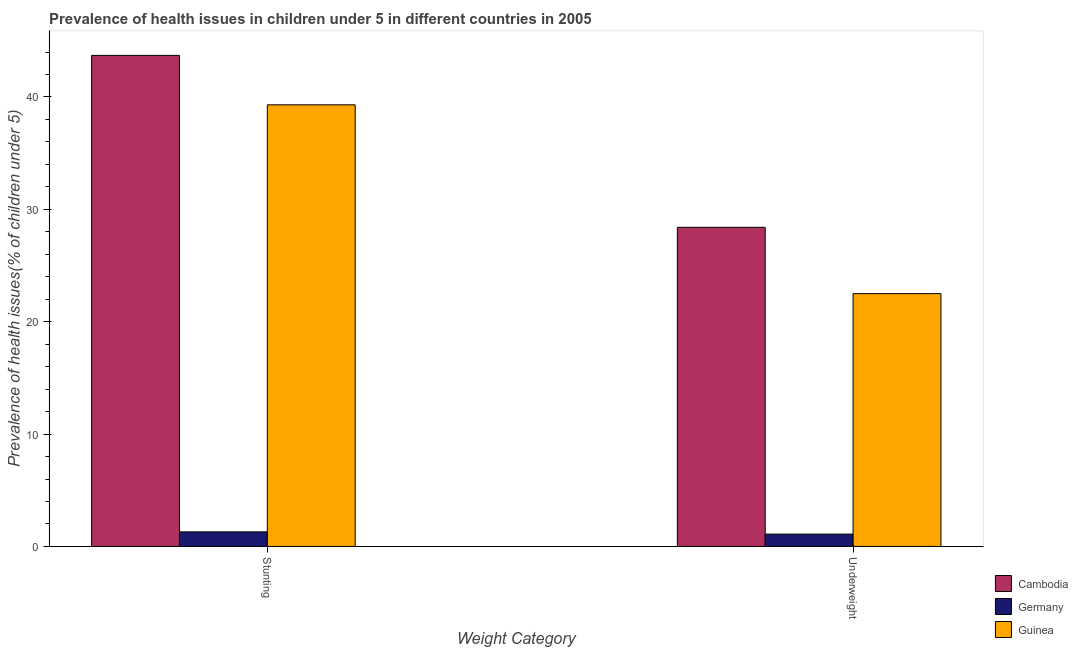Are the number of bars on each tick of the X-axis equal?
Make the answer very short. Yes. What is the label of the 1st group of bars from the left?
Your response must be concise. Stunting. What is the percentage of stunted children in Guinea?
Provide a succinct answer. 39.3. Across all countries, what is the maximum percentage of stunted children?
Give a very brief answer. 43.7. Across all countries, what is the minimum percentage of underweight children?
Your answer should be very brief. 1.1. In which country was the percentage of underweight children maximum?
Your response must be concise. Cambodia. What is the total percentage of stunted children in the graph?
Keep it short and to the point. 84.3. What is the difference between the percentage of stunted children in Guinea and that in Germany?
Keep it short and to the point. 38. What is the difference between the percentage of underweight children in Cambodia and the percentage of stunted children in Germany?
Give a very brief answer. 27.1. What is the average percentage of underweight children per country?
Your answer should be compact. 17.33. What is the difference between the percentage of underweight children and percentage of stunted children in Guinea?
Your answer should be compact. -16.8. In how many countries, is the percentage of stunted children greater than 40 %?
Your answer should be very brief. 1. What is the ratio of the percentage of underweight children in Cambodia to that in Guinea?
Offer a terse response. 1.26. In how many countries, is the percentage of stunted children greater than the average percentage of stunted children taken over all countries?
Give a very brief answer. 2. What does the 1st bar from the right in Underweight represents?
Your answer should be compact. Guinea. How many bars are there?
Offer a terse response. 6. Are all the bars in the graph horizontal?
Provide a short and direct response. No. What is the difference between two consecutive major ticks on the Y-axis?
Your answer should be very brief. 10. Are the values on the major ticks of Y-axis written in scientific E-notation?
Offer a very short reply. No. How are the legend labels stacked?
Ensure brevity in your answer.  Vertical. What is the title of the graph?
Ensure brevity in your answer.  Prevalence of health issues in children under 5 in different countries in 2005. What is the label or title of the X-axis?
Provide a succinct answer. Weight Category. What is the label or title of the Y-axis?
Make the answer very short. Prevalence of health issues(% of children under 5). What is the Prevalence of health issues(% of children under 5) of Cambodia in Stunting?
Your answer should be very brief. 43.7. What is the Prevalence of health issues(% of children under 5) of Germany in Stunting?
Your response must be concise. 1.3. What is the Prevalence of health issues(% of children under 5) of Guinea in Stunting?
Keep it short and to the point. 39.3. What is the Prevalence of health issues(% of children under 5) in Cambodia in Underweight?
Offer a terse response. 28.4. What is the Prevalence of health issues(% of children under 5) of Germany in Underweight?
Provide a succinct answer. 1.1. Across all Weight Category, what is the maximum Prevalence of health issues(% of children under 5) of Cambodia?
Provide a succinct answer. 43.7. Across all Weight Category, what is the maximum Prevalence of health issues(% of children under 5) of Germany?
Give a very brief answer. 1.3. Across all Weight Category, what is the maximum Prevalence of health issues(% of children under 5) of Guinea?
Your response must be concise. 39.3. Across all Weight Category, what is the minimum Prevalence of health issues(% of children under 5) in Cambodia?
Provide a succinct answer. 28.4. Across all Weight Category, what is the minimum Prevalence of health issues(% of children under 5) in Germany?
Provide a succinct answer. 1.1. What is the total Prevalence of health issues(% of children under 5) of Cambodia in the graph?
Make the answer very short. 72.1. What is the total Prevalence of health issues(% of children under 5) in Guinea in the graph?
Your answer should be very brief. 61.8. What is the difference between the Prevalence of health issues(% of children under 5) of Cambodia in Stunting and the Prevalence of health issues(% of children under 5) of Germany in Underweight?
Make the answer very short. 42.6. What is the difference between the Prevalence of health issues(% of children under 5) in Cambodia in Stunting and the Prevalence of health issues(% of children under 5) in Guinea in Underweight?
Give a very brief answer. 21.2. What is the difference between the Prevalence of health issues(% of children under 5) of Germany in Stunting and the Prevalence of health issues(% of children under 5) of Guinea in Underweight?
Provide a succinct answer. -21.2. What is the average Prevalence of health issues(% of children under 5) in Cambodia per Weight Category?
Offer a very short reply. 36.05. What is the average Prevalence of health issues(% of children under 5) in Germany per Weight Category?
Provide a short and direct response. 1.2. What is the average Prevalence of health issues(% of children under 5) of Guinea per Weight Category?
Your response must be concise. 30.9. What is the difference between the Prevalence of health issues(% of children under 5) of Cambodia and Prevalence of health issues(% of children under 5) of Germany in Stunting?
Offer a very short reply. 42.4. What is the difference between the Prevalence of health issues(% of children under 5) of Cambodia and Prevalence of health issues(% of children under 5) of Guinea in Stunting?
Offer a very short reply. 4.4. What is the difference between the Prevalence of health issues(% of children under 5) of Germany and Prevalence of health issues(% of children under 5) of Guinea in Stunting?
Offer a very short reply. -38. What is the difference between the Prevalence of health issues(% of children under 5) in Cambodia and Prevalence of health issues(% of children under 5) in Germany in Underweight?
Provide a short and direct response. 27.3. What is the difference between the Prevalence of health issues(% of children under 5) in Germany and Prevalence of health issues(% of children under 5) in Guinea in Underweight?
Ensure brevity in your answer.  -21.4. What is the ratio of the Prevalence of health issues(% of children under 5) in Cambodia in Stunting to that in Underweight?
Your answer should be very brief. 1.54. What is the ratio of the Prevalence of health issues(% of children under 5) in Germany in Stunting to that in Underweight?
Your answer should be compact. 1.18. What is the ratio of the Prevalence of health issues(% of children under 5) of Guinea in Stunting to that in Underweight?
Offer a very short reply. 1.75. What is the difference between the highest and the second highest Prevalence of health issues(% of children under 5) in Cambodia?
Ensure brevity in your answer.  15.3. What is the difference between the highest and the second highest Prevalence of health issues(% of children under 5) of Guinea?
Your response must be concise. 16.8. What is the difference between the highest and the lowest Prevalence of health issues(% of children under 5) in Cambodia?
Your answer should be compact. 15.3. What is the difference between the highest and the lowest Prevalence of health issues(% of children under 5) in Germany?
Ensure brevity in your answer.  0.2. What is the difference between the highest and the lowest Prevalence of health issues(% of children under 5) of Guinea?
Your answer should be very brief. 16.8. 